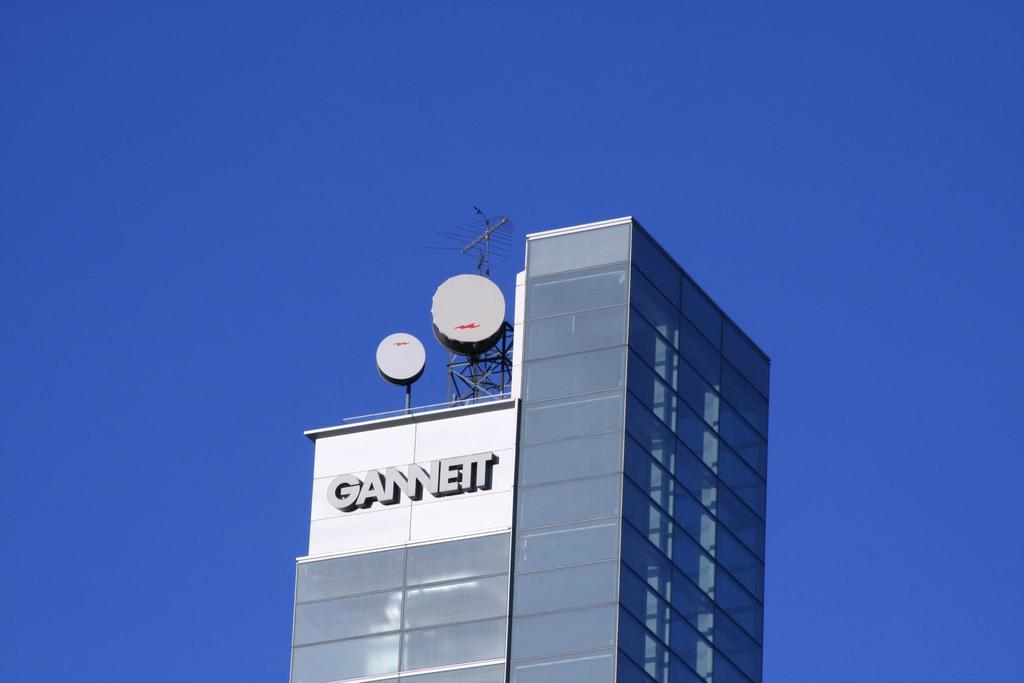What type of building is in the image? There is a glass building in the image. What else can be seen in the image besides the building? There are objects visible in the image. Can you describe any specific features of the building? An antenna is present in the image. What is the condition of the sky in the background of the image? The sky is clear in the background of the image. How many ants can be seen crawling on the antenna in the image? There are no ants visible in the image, as it only features a glass building, objects, an antenna, and a clear sky in the background. 